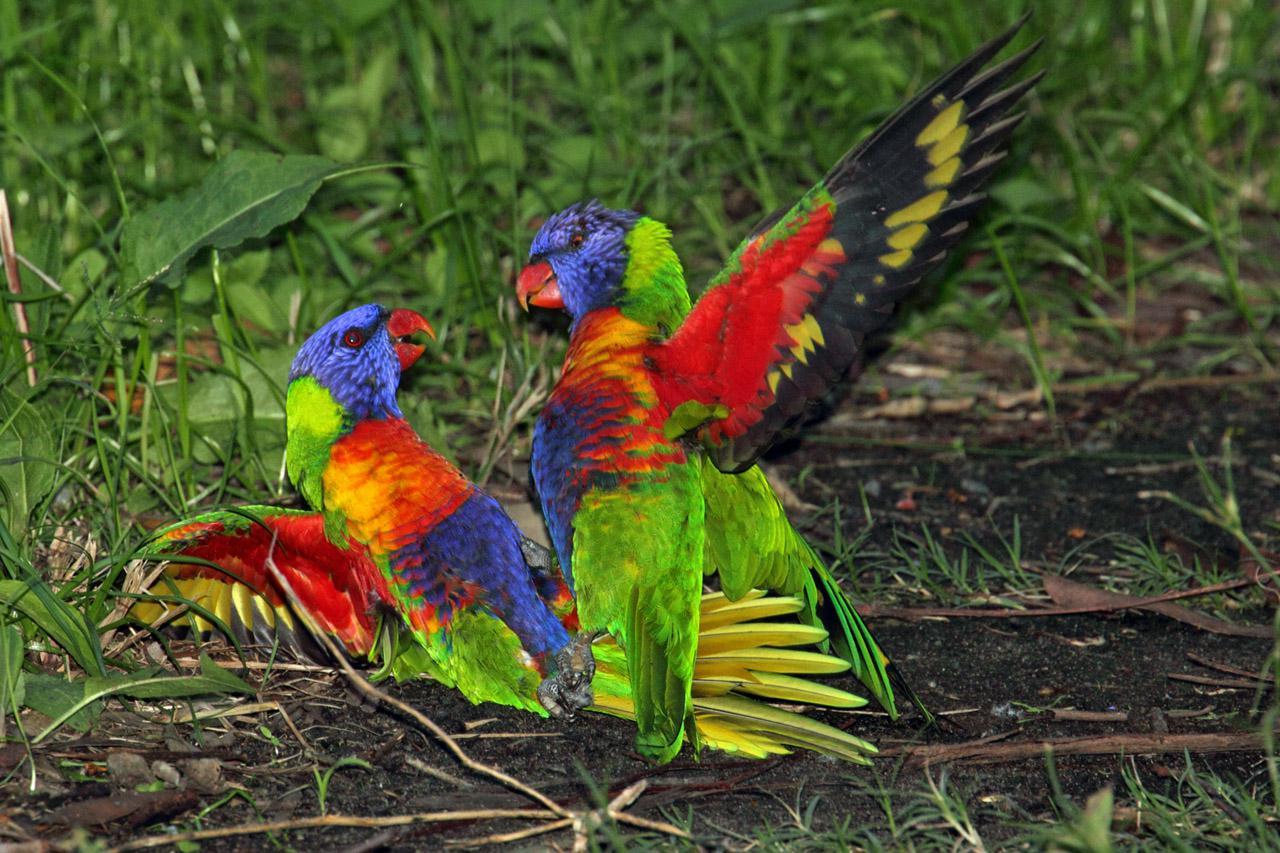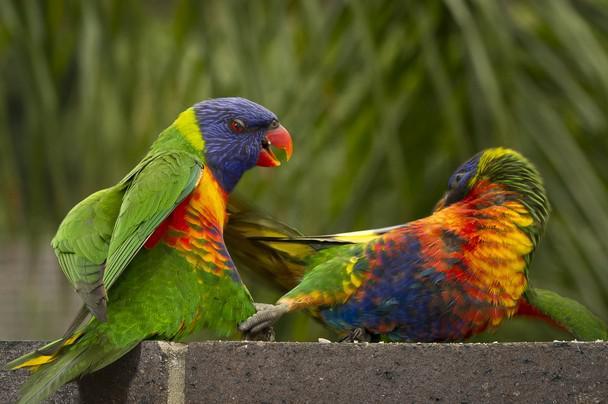The first image is the image on the left, the second image is the image on the right. Examine the images to the left and right. Is the description "There are no less than five colorful birds" accurate? Answer yes or no. No. The first image is the image on the left, the second image is the image on the right. Analyze the images presented: Is the assertion "There are no more than two parrots in the right image." valid? Answer yes or no. Yes. 